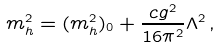Convert formula to latex. <formula><loc_0><loc_0><loc_500><loc_500>m _ { h } ^ { 2 } = ( m _ { h } ^ { 2 } ) _ { 0 } + \frac { c g ^ { 2 } } { 1 6 \pi ^ { 2 } } \Lambda ^ { 2 } \, ,</formula> 